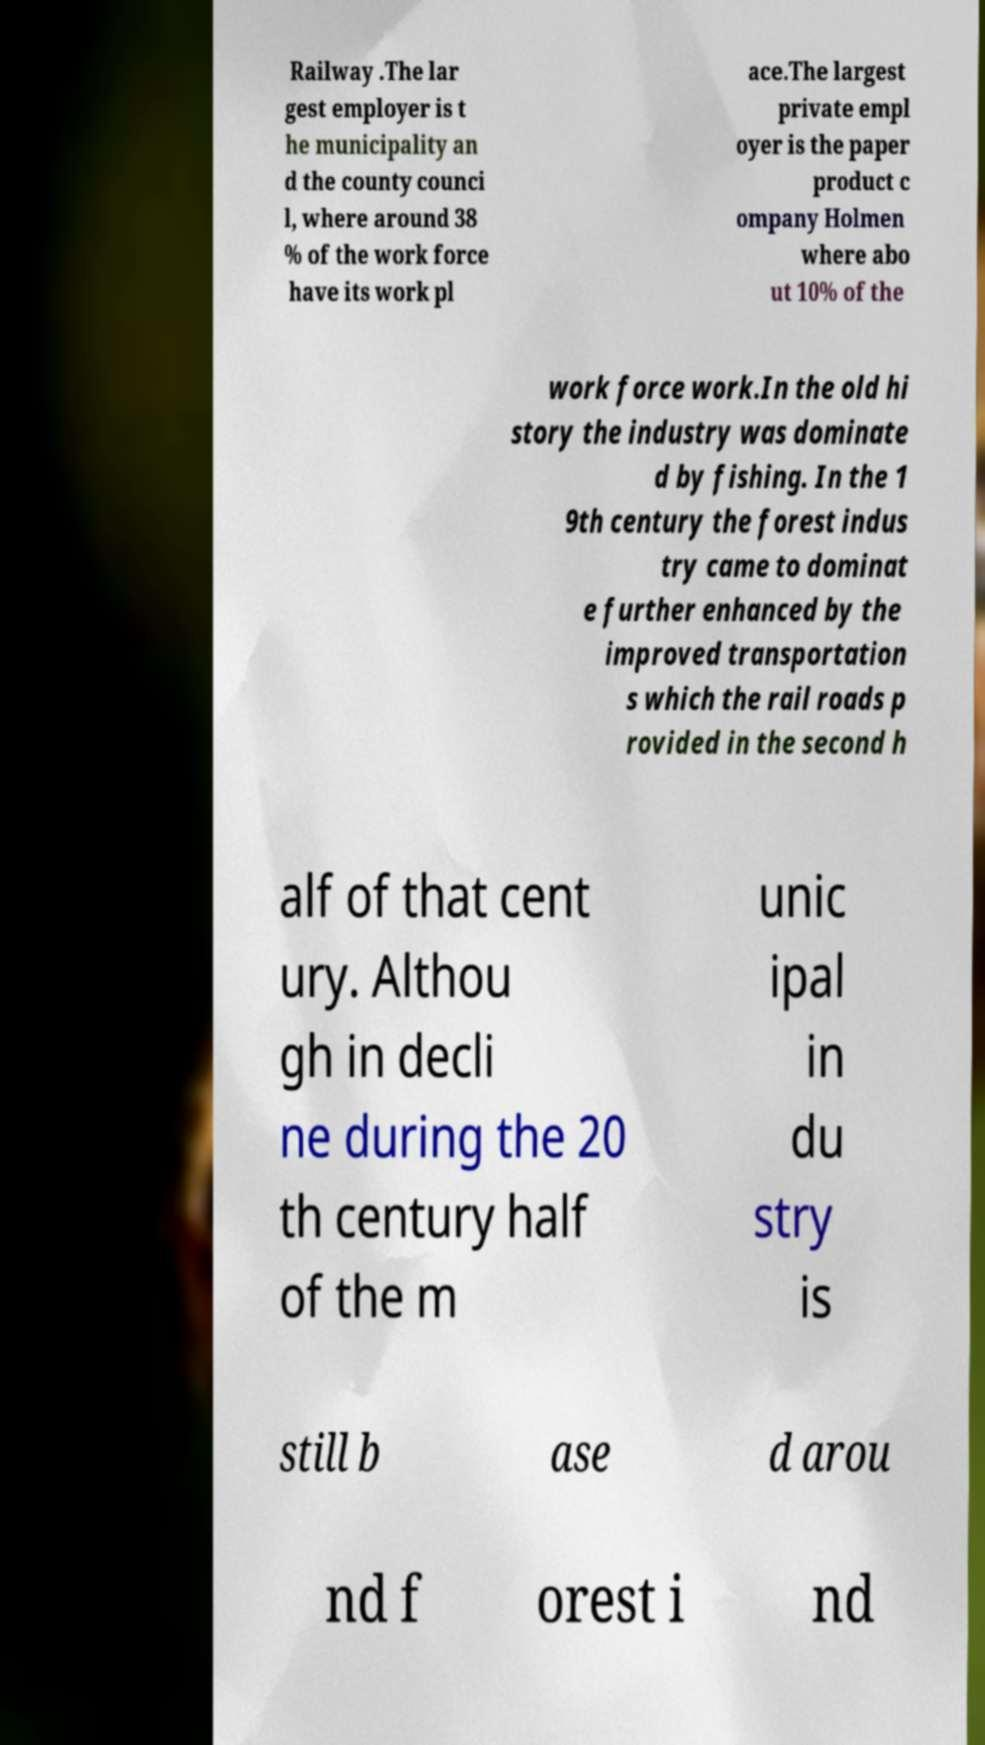Can you read and provide the text displayed in the image?This photo seems to have some interesting text. Can you extract and type it out for me? Railway .The lar gest employer is t he municipality an d the county counci l, where around 38 % of the work force have its work pl ace.The largest private empl oyer is the paper product c ompany Holmen where abo ut 10% of the work force work.In the old hi story the industry was dominate d by fishing. In the 1 9th century the forest indus try came to dominat e further enhanced by the improved transportation s which the rail roads p rovided in the second h alf of that cent ury. Althou gh in decli ne during the 20 th century half of the m unic ipal in du stry is still b ase d arou nd f orest i nd 